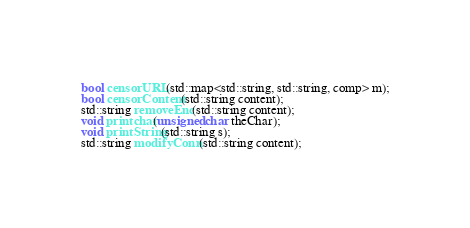Convert code to text. <code><loc_0><loc_0><loc_500><loc_500><_C_>bool censorURL(std::map<std::string, std::string, comp> m);
bool censorContent(std::string content);
std::string removeEnc(std::string content);
void printchar(unsigned char theChar);
void printString(std::string s);
std::string modifyConn(std::string content);
</code> 